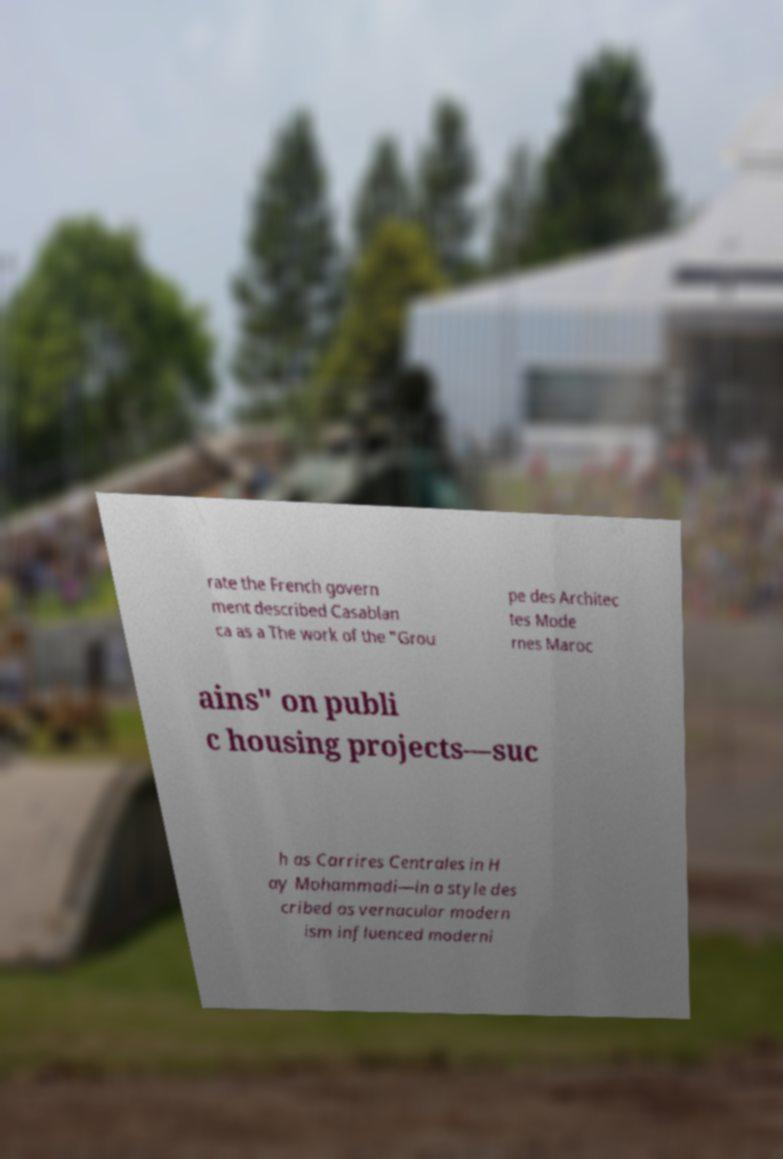Please identify and transcribe the text found in this image. rate the French govern ment described Casablan ca as a The work of the "Grou pe des Architec tes Mode rnes Maroc ains" on publi c housing projects—suc h as Carrires Centrales in H ay Mohammadi—in a style des cribed as vernacular modern ism influenced moderni 